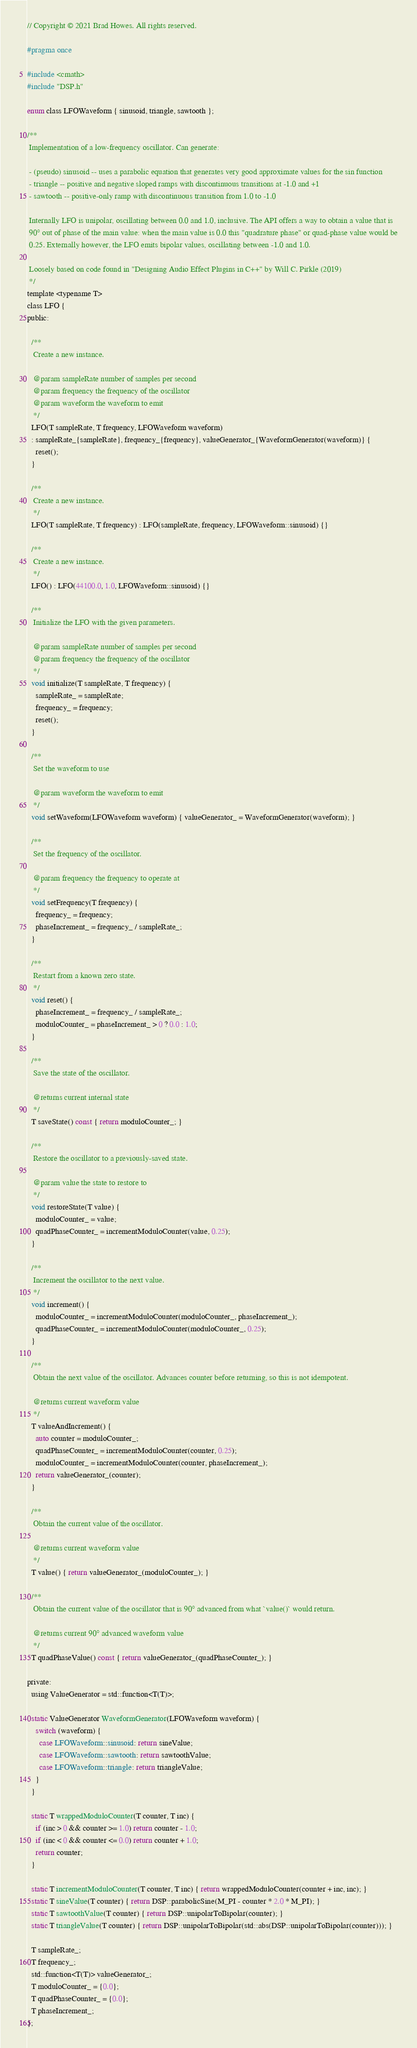<code> <loc_0><loc_0><loc_500><loc_500><_C_>// Copyright © 2021 Brad Howes. All rights reserved.

#pragma once

#include <cmath>
#include "DSP.h"

enum class LFOWaveform { sinusoid, triangle, sawtooth };

/**
 Implementation of a low-frequency oscillator. Can generate:
 
 - (pseudo) sinusoid -- uses a parabolic equation that generates very good approximate values for the sin function
 - triangle -- positive and negative sloped ramps with discontinuous transitions at -1.0 and +1
 - sawtooth -- positive-only ramp with discontinuous transition from 1.0 to -1.0
 
 Internally LFO is unipolar, oscillating between 0.0 and 1.0, inclusive. The API offers a way to obtain a value that is
 90° out of phase of the main value: when the main value is 0.0 this "quadrature phase" or quad-phase value would be
 0.25. Externally however, the LFO emits bipolar values, oscillating between -1.0 and 1.0.
 
 Loosely based on code found in "Designing Audio Effect Plugins in C++" by Will C. Pirkle (2019)
 */
template <typename T>
class LFO {
public:
  
  /**
   Create a new instance.
   
   @param sampleRate number of samples per second
   @param frequency the frequency of the oscillator
   @param waveform the waveform to emit
   */
  LFO(T sampleRate, T frequency, LFOWaveform waveform)
  : sampleRate_{sampleRate}, frequency_{frequency}, valueGenerator_{WaveformGenerator(waveform)} {
    reset();
  }
  
  /**
   Create a new instance.
   */
  LFO(T sampleRate, T frequency) : LFO(sampleRate, frequency, LFOWaveform::sinusoid) {}
  
  /**
   Create a new instance.
   */
  LFO() : LFO(44100.0, 1.0, LFOWaveform::sinusoid) {}
  
  /**
   Initialize the LFO with the given parameters.
   
   @param sampleRate number of samples per second
   @param frequency the frequency of the oscillator
   */
  void initialize(T sampleRate, T frequency) {
    sampleRate_ = sampleRate;
    frequency_ = frequency;
    reset();
  }
  
  /**
   Set the waveform to use
   
   @param waveform the waveform to emit
   */
  void setWaveform(LFOWaveform waveform) { valueGenerator_ = WaveformGenerator(waveform); }
  
  /**
   Set the frequency of the oscillator.
   
   @param frequency the frequency to operate at
   */
  void setFrequency(T frequency) {
    frequency_ = frequency;
    phaseIncrement_ = frequency_ / sampleRate_;
  }
  
  /**
   Restart from a known zero state.
   */
  void reset() {
    phaseIncrement_ = frequency_ / sampleRate_;
    moduloCounter_ = phaseIncrement_ > 0 ? 0.0 : 1.0;
  }
  
  /**
   Save the state of the oscillator.
   
   @returns current internal state
   */
  T saveState() const { return moduloCounter_; }
  
  /**
   Restore the oscillator to a previously-saved state.
   
   @param value the state to restore to
   */
  void restoreState(T value) {
    moduloCounter_ = value;
    quadPhaseCounter_ = incrementModuloCounter(value, 0.25);
  }
  
  /**
   Increment the oscillator to the next value.
   */
  void increment() {
    moduloCounter_ = incrementModuloCounter(moduloCounter_, phaseIncrement_);
    quadPhaseCounter_ = incrementModuloCounter(moduloCounter_, 0.25);
  }
  
  /**
   Obtain the next value of the oscillator. Advances counter before returning, so this is not idempotent.
   
   @returns current waveform value
   */
  T valueAndIncrement() {
    auto counter = moduloCounter_;
    quadPhaseCounter_ = incrementModuloCounter(counter, 0.25);
    moduloCounter_ = incrementModuloCounter(counter, phaseIncrement_);
    return valueGenerator_(counter);
  }
  
  /**
   Obtain the current value of the oscillator.
   
   @returns current waveform value
   */
  T value() { return valueGenerator_(moduloCounter_); }
  
  /**
   Obtain the current value of the oscillator that is 90° advanced from what `value()` would return.
   
   @returns current 90° advanced waveform value
   */
  T quadPhaseValue() const { return valueGenerator_(quadPhaseCounter_); }
  
private:
  using ValueGenerator = std::function<T(T)>;
  
  static ValueGenerator WaveformGenerator(LFOWaveform waveform) {
    switch (waveform) {
      case LFOWaveform::sinusoid: return sineValue;
      case LFOWaveform::sawtooth: return sawtoothValue;
      case LFOWaveform::triangle: return triangleValue;
    }
  }
  
  static T wrappedModuloCounter(T counter, T inc) {
    if (inc > 0 && counter >= 1.0) return counter - 1.0;
    if (inc < 0 && counter <= 0.0) return counter + 1.0;
    return counter;
  }
  
  static T incrementModuloCounter(T counter, T inc) { return wrappedModuloCounter(counter + inc, inc); }
  static T sineValue(T counter) { return DSP::parabolicSine(M_PI - counter * 2.0 * M_PI); }
  static T sawtoothValue(T counter) { return DSP::unipolarToBipolar(counter); }
  static T triangleValue(T counter) { return DSP::unipolarToBipolar(std::abs(DSP::unipolarToBipolar(counter))); }
  
  T sampleRate_;
  T frequency_;
  std::function<T(T)> valueGenerator_;
  T moduloCounter_ = {0.0};
  T quadPhaseCounter_ = {0.0};
  T phaseIncrement_;
};
</code> 